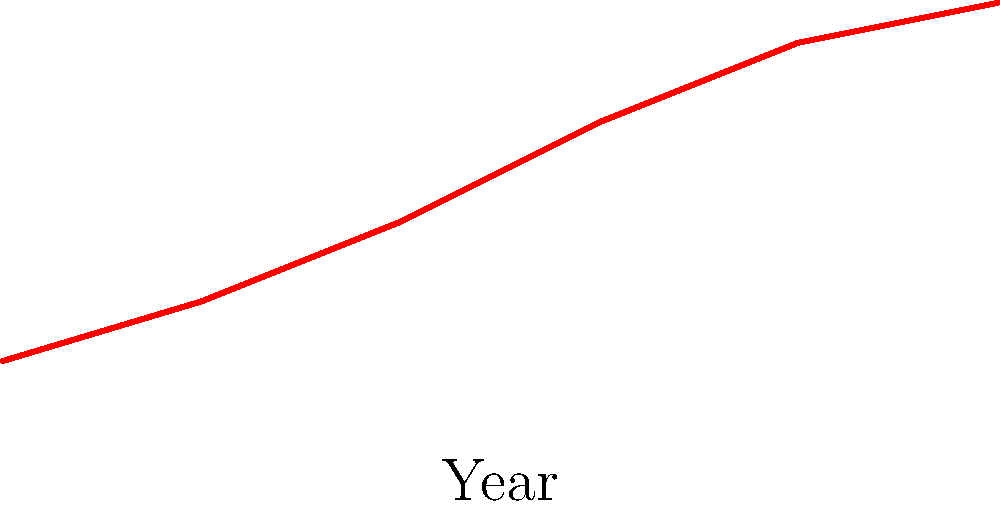Based on the graph showing the relative value of antique family heirlooms over time, estimate the age of a piece that has a relative value of 80. How many years old is it approximately? To estimate the age of the antique with a relative value of 80, we'll follow these steps:

1. Locate the value of 80 on the y-axis (Relative Value).
2. Draw an imaginary horizontal line from this point to intersect the curve.
3. From the intersection point, draw a vertical line down to the x-axis (Year).
4. Read the corresponding year on the x-axis.
5. Calculate the age by subtracting this year from the current year.

From the graph, we can see that a relative value of 80 corresponds to approximately the year 1925.

Assuming the current year is 2023:

$\text{Age} = 2023 - 1925 = 98$ years

Therefore, the antique piece is approximately 98 years old.
Answer: 98 years 